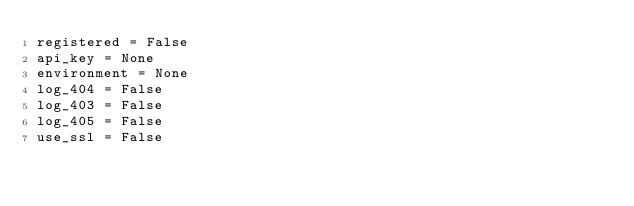<code> <loc_0><loc_0><loc_500><loc_500><_Python_>registered = False
api_key = None
environment = None
log_404 = False
log_403 = False
log_405 = False
use_ssl = False</code> 